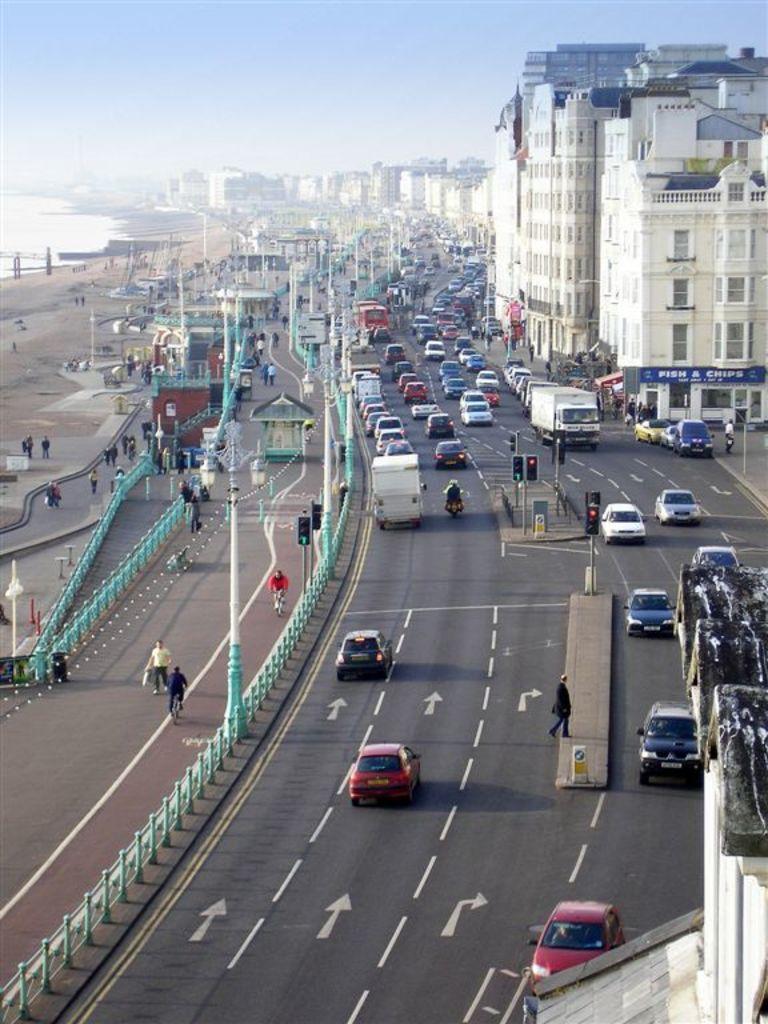Describe this image in one or two sentences. In this picture we can see vehicles and a person on the road. In the middle of the road, there are poles with traffic lights. On the right side of the image, there are buildings. On the left side of the image, there are poles, railings, some objects and the sea and there are groups of people, among them few people walking and two persons riding the bicycles on the road. At the top of the image, there is the sky. 